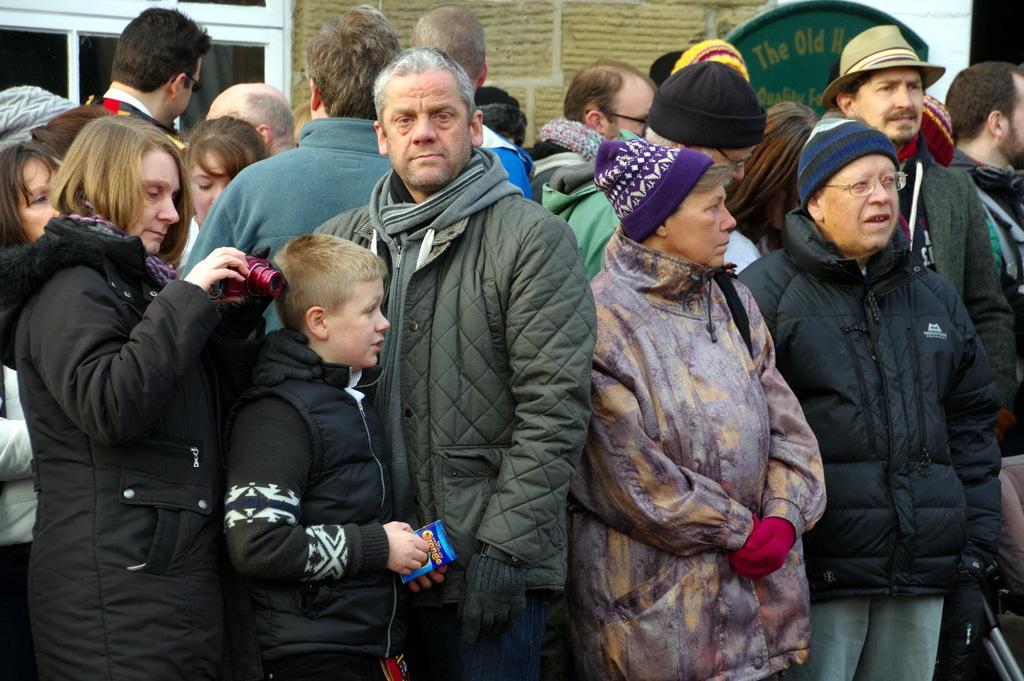How would you summarize this image in a sentence or two? In this image there are group of people standing one beside the other. In the background it seems like a building with glass windows. In the middle there is a kid who is holding the packet. 